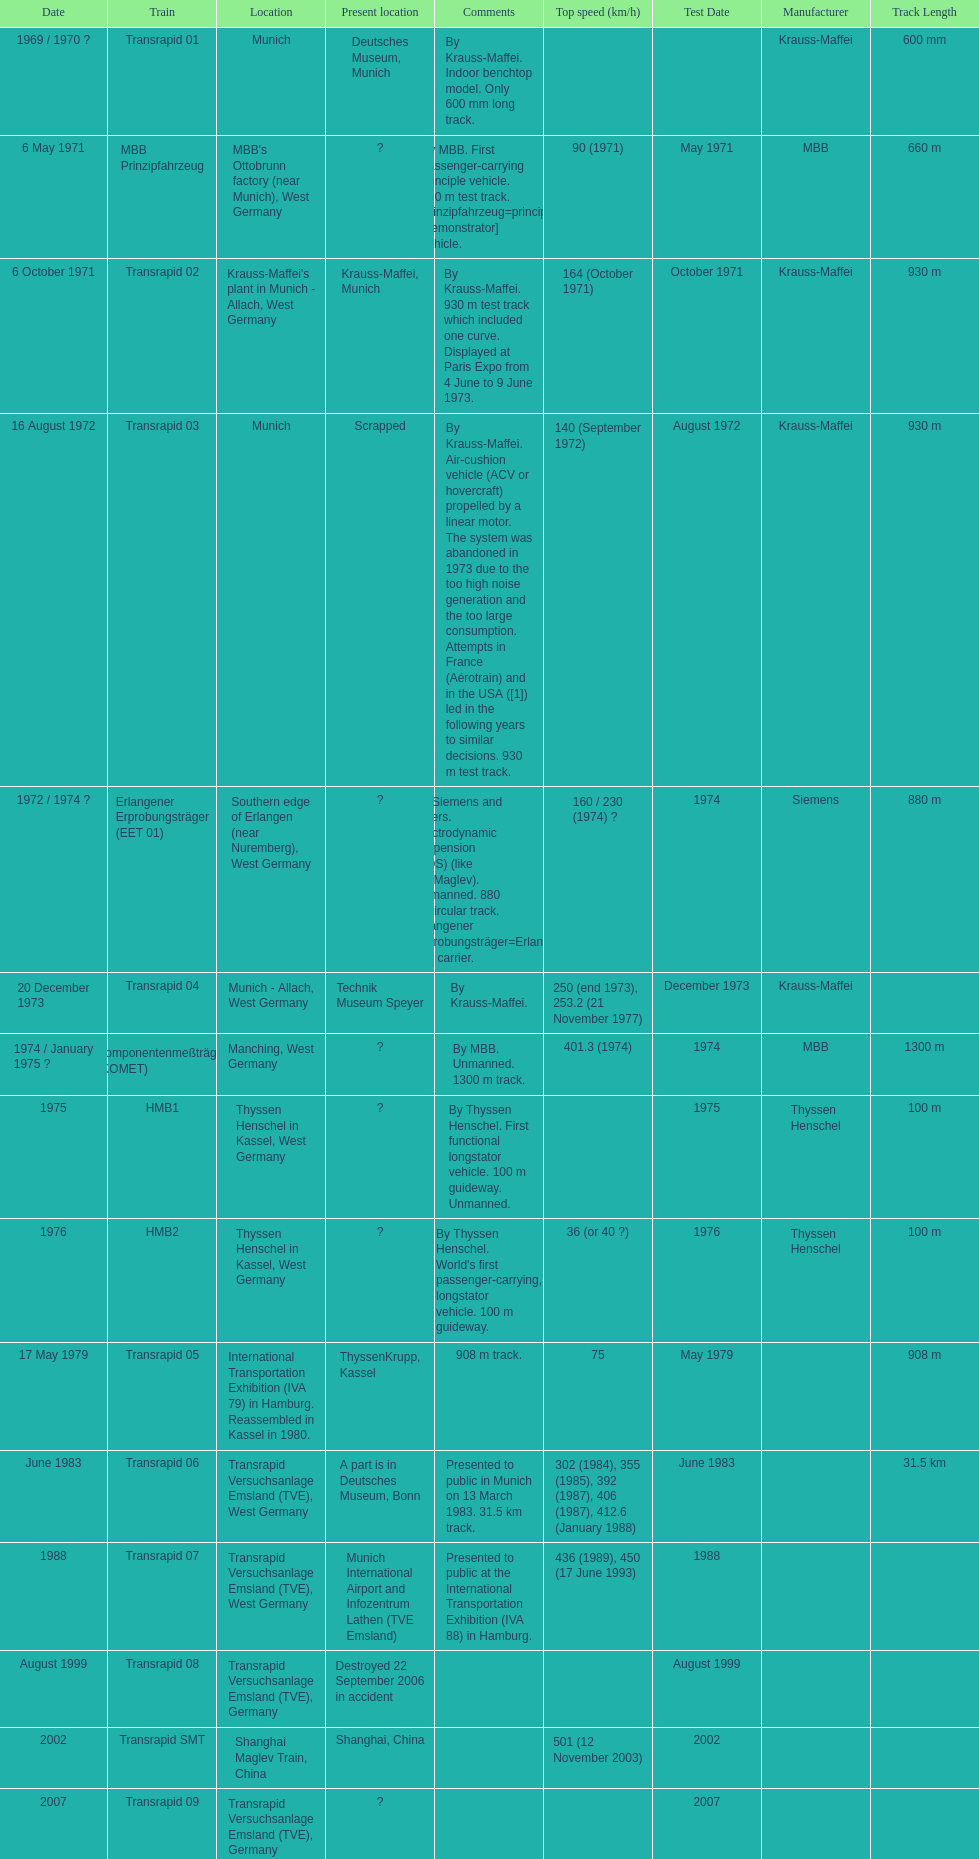Would you mind parsing the complete table? {'header': ['Date', 'Train', 'Location', 'Present location', 'Comments', 'Top speed (km/h)', 'Test Date', 'Manufacturer', 'Track Length'], 'rows': [['1969 / 1970\xa0?', 'Transrapid 01', 'Munich', 'Deutsches Museum, Munich', 'By Krauss-Maffei. Indoor benchtop model. Only 600\xa0mm long track.', '', '', 'Krauss-Maffei', '600 mm'], ['6 May 1971', 'MBB Prinzipfahrzeug', "MBB's Ottobrunn factory (near Munich), West Germany", '?', 'By MBB. First passenger-carrying principle vehicle. 660 m test track. Prinzipfahrzeug=principle [demonstrator] vehicle.', '90 (1971)', 'May 1971', 'MBB', '660 m'], ['6 October 1971', 'Transrapid 02', "Krauss-Maffei's plant in Munich - Allach, West Germany", 'Krauss-Maffei, Munich', 'By Krauss-Maffei. 930 m test track which included one curve. Displayed at Paris Expo from 4 June to 9 June 1973.', '164 (October 1971)', 'October 1971', 'Krauss-Maffei', '930 m'], ['16 August 1972', 'Transrapid 03', 'Munich', 'Scrapped', 'By Krauss-Maffei. Air-cushion vehicle (ACV or hovercraft) propelled by a linear motor. The system was abandoned in 1973 due to the too high noise generation and the too large consumption. Attempts in France (Aérotrain) and in the USA ([1]) led in the following years to similar decisions. 930 m test track.', '140 (September 1972)', 'August 1972', 'Krauss-Maffei', '930 m'], ['1972 / 1974\xa0?', 'Erlangener Erprobungsträger (EET 01)', 'Southern edge of Erlangen (near Nuremberg), West Germany', '?', 'By Siemens and others. Electrodynamic suspension (EDS) (like JR-Maglev). Unmanned. 880 m circular track. Erlangener Erprobungsträger=Erlangen test carrier.', '160 / 230 (1974)\xa0?', '1974', 'Siemens', '880 m'], ['20 December 1973', 'Transrapid 04', 'Munich - Allach, West Germany', 'Technik Museum Speyer', 'By Krauss-Maffei.', '250 (end 1973), 253.2 (21 November 1977)', 'December 1973', 'Krauss-Maffei', ''], ['1974 / January 1975\xa0?', 'Komponentenmeßträger (KOMET)', 'Manching, West Germany', '?', 'By MBB. Unmanned. 1300 m track.', '401.3 (1974)', '1974', 'MBB', '1300 m'], ['1975', 'HMB1', 'Thyssen Henschel in Kassel, West Germany', '?', 'By Thyssen Henschel. First functional longstator vehicle. 100 m guideway. Unmanned.', '', '1975', 'Thyssen Henschel', '100 m'], ['1976', 'HMB2', 'Thyssen Henschel in Kassel, West Germany', '?', "By Thyssen Henschel. World's first passenger-carrying, longstator vehicle. 100 m guideway.", '36 (or 40\xa0?)', '1976', 'Thyssen Henschel', '100 m'], ['17 May 1979', 'Transrapid 05', 'International Transportation Exhibition (IVA 79) in Hamburg. Reassembled in Kassel in 1980.', 'ThyssenKrupp, Kassel', '908 m track.', '75', 'May 1979', '', '908 m'], ['June 1983', 'Transrapid 06', 'Transrapid Versuchsanlage Emsland (TVE), West Germany', 'A part is in Deutsches Museum, Bonn', 'Presented to public in Munich on 13 March 1983. 31.5\xa0km track.', '302 (1984), 355 (1985), 392 (1987), 406 (1987), 412.6 (January 1988)', 'June 1983', '', '31.5 km'], ['1988', 'Transrapid 07', 'Transrapid Versuchsanlage Emsland (TVE), West Germany', 'Munich International Airport and Infozentrum Lathen (TVE Emsland)', 'Presented to public at the International Transportation Exhibition (IVA 88) in Hamburg.', '436 (1989), 450 (17 June 1993)', '1988', '', ''], ['August 1999', 'Transrapid 08', 'Transrapid Versuchsanlage Emsland (TVE), Germany', 'Destroyed 22 September 2006 in accident', '', '', 'August 1999', '', ''], ['2002', 'Transrapid SMT', 'Shanghai Maglev Train, China', 'Shanghai, China', '', '501 (12 November 2003)', '2002', '', ''], ['2007', 'Transrapid 09', 'Transrapid Versuchsanlage Emsland (TVE), Germany', '?', '', '', '2007', '', '']]} How many trains listed have the same speed as the hmb2? 0. 